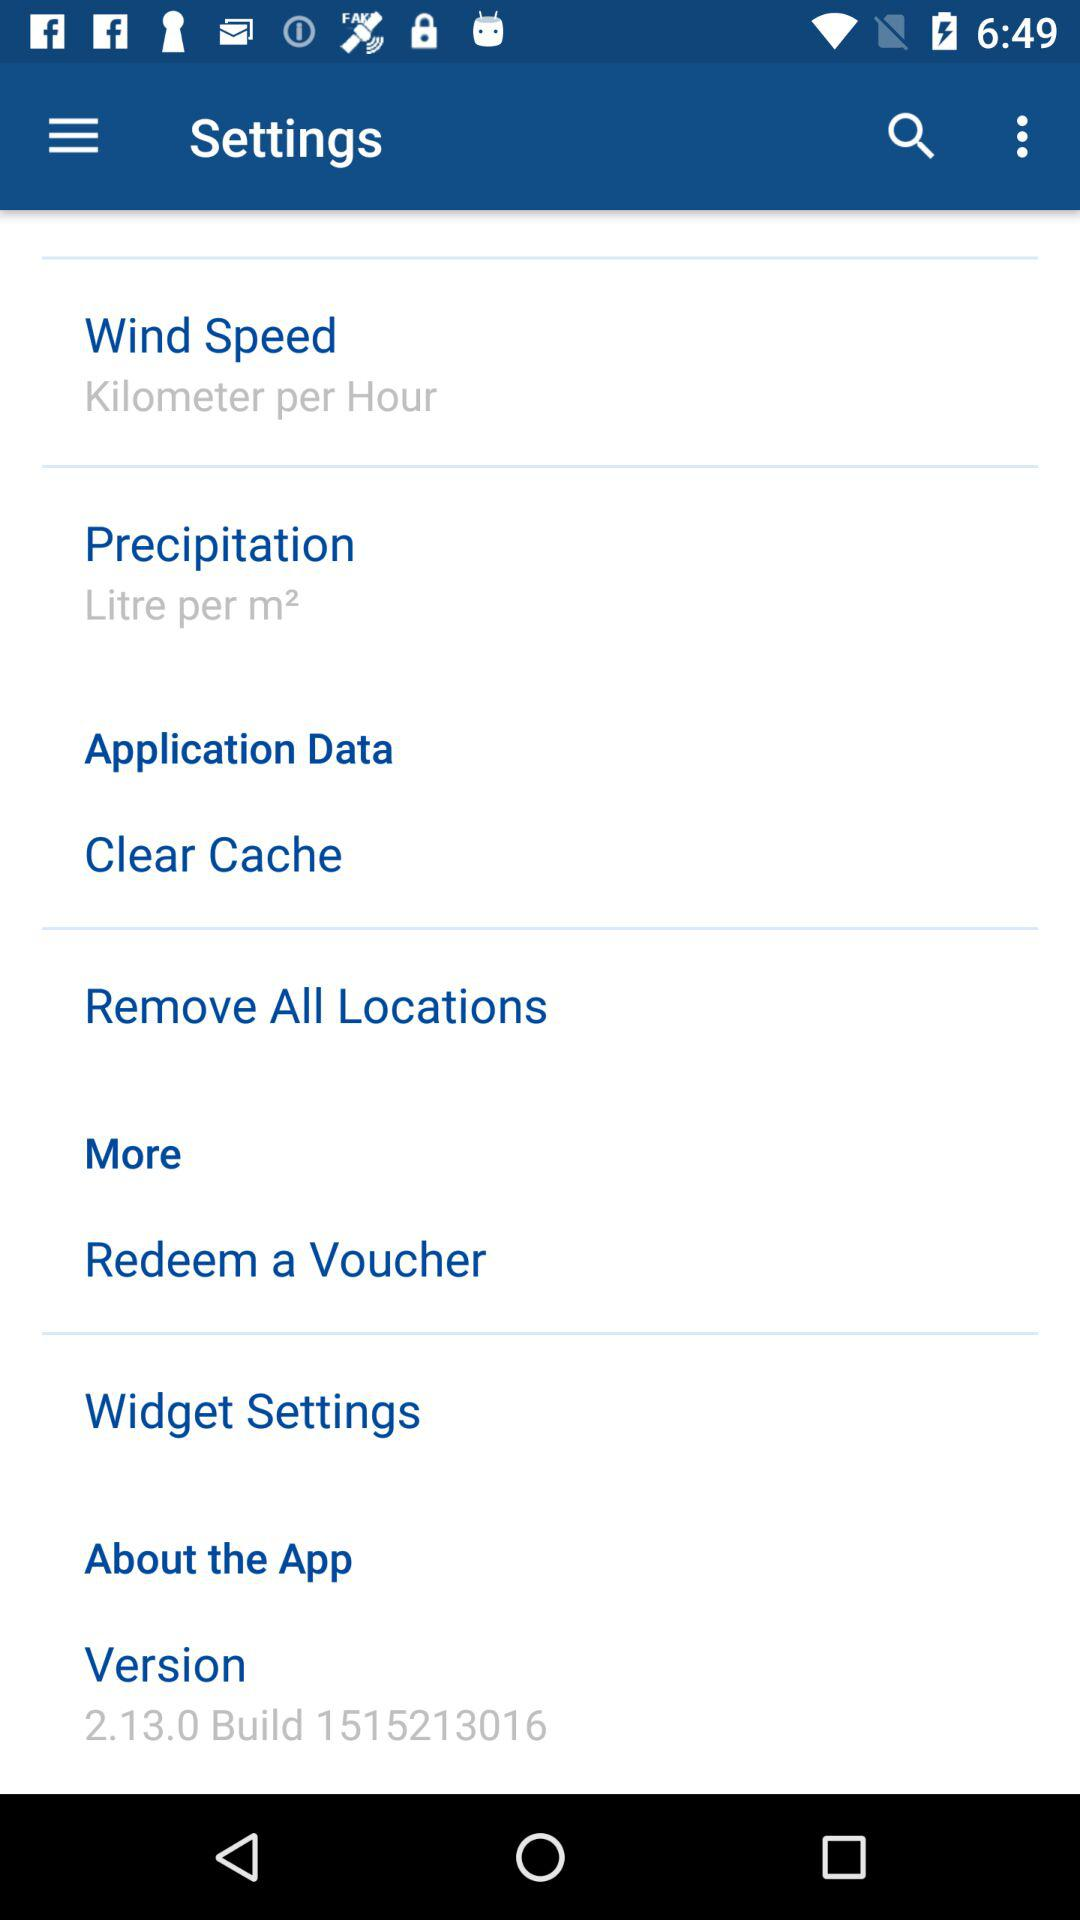What is the unit of precipitation? The unit of precipitation is litre per m². 